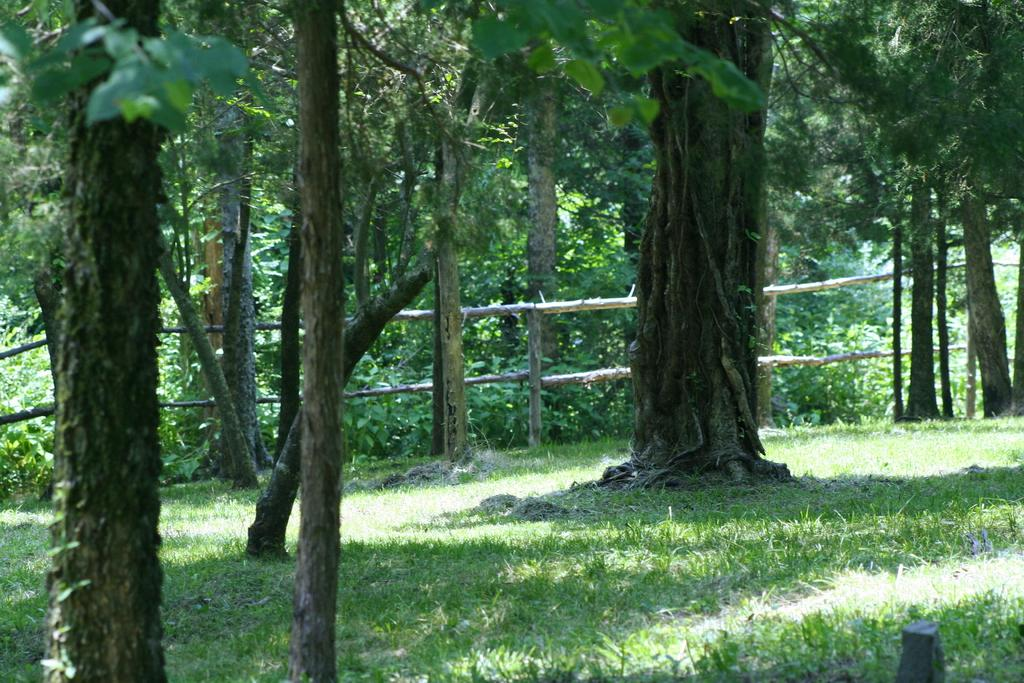What type of vegetation is present in the image? There is grass in the image. What can be observed about the lighting in the image? There are shadows visible in the image. What other natural elements can be seen in the image? There are trees in the image. What type of angle is being used to take the picture in the image? There is no information provided about the angle used to take the picture in the image. How many cows are grazing in the grass in the image? There is no mention of cows in the image; it only features grass, shadows, and trees. What type of industrial buildings can be seen in the background of the image? There is no mention of industrial buildings in the image; it only features grass, shadows, and trees. 